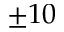<formula> <loc_0><loc_0><loc_500><loc_500>\pm 1 0</formula> 